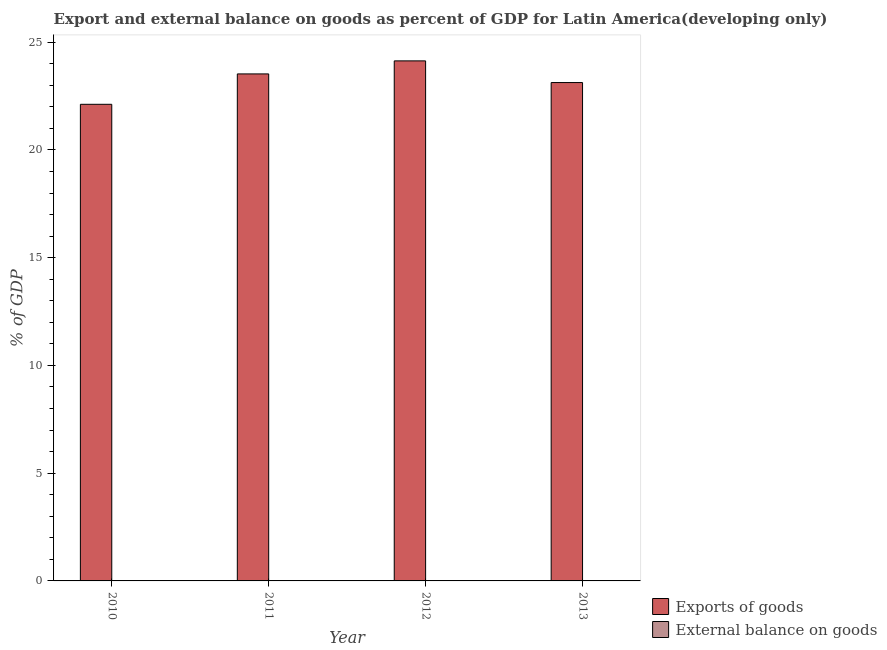How many bars are there on the 4th tick from the left?
Provide a short and direct response. 1. How many bars are there on the 4th tick from the right?
Your response must be concise. 1. What is the external balance on goods as percentage of gdp in 2010?
Offer a terse response. 0. Across all years, what is the maximum export of goods as percentage of gdp?
Keep it short and to the point. 24.13. Across all years, what is the minimum export of goods as percentage of gdp?
Offer a very short reply. 22.12. What is the total export of goods as percentage of gdp in the graph?
Offer a very short reply. 92.9. What is the difference between the export of goods as percentage of gdp in 2010 and that in 2012?
Your answer should be very brief. -2.02. What is the difference between the external balance on goods as percentage of gdp in 2013 and the export of goods as percentage of gdp in 2011?
Provide a short and direct response. 0. In how many years, is the export of goods as percentage of gdp greater than 24 %?
Offer a terse response. 1. What is the ratio of the export of goods as percentage of gdp in 2011 to that in 2012?
Make the answer very short. 0.97. Is the difference between the export of goods as percentage of gdp in 2012 and 2013 greater than the difference between the external balance on goods as percentage of gdp in 2012 and 2013?
Offer a terse response. No. What is the difference between the highest and the second highest export of goods as percentage of gdp?
Keep it short and to the point. 0.61. What is the difference between the highest and the lowest export of goods as percentage of gdp?
Offer a terse response. 2.02. In how many years, is the external balance on goods as percentage of gdp greater than the average external balance on goods as percentage of gdp taken over all years?
Your answer should be very brief. 0. How many bars are there?
Your answer should be very brief. 4. Are all the bars in the graph horizontal?
Keep it short and to the point. No. How many years are there in the graph?
Make the answer very short. 4. What is the difference between two consecutive major ticks on the Y-axis?
Provide a short and direct response. 5. Where does the legend appear in the graph?
Offer a terse response. Bottom right. How many legend labels are there?
Your answer should be compact. 2. What is the title of the graph?
Provide a short and direct response. Export and external balance on goods as percent of GDP for Latin America(developing only). What is the label or title of the X-axis?
Your answer should be compact. Year. What is the label or title of the Y-axis?
Your response must be concise. % of GDP. What is the % of GDP of Exports of goods in 2010?
Provide a succinct answer. 22.12. What is the % of GDP of Exports of goods in 2011?
Your response must be concise. 23.53. What is the % of GDP of Exports of goods in 2012?
Your answer should be very brief. 24.13. What is the % of GDP of External balance on goods in 2012?
Offer a very short reply. 0. What is the % of GDP of Exports of goods in 2013?
Ensure brevity in your answer.  23.13. What is the % of GDP in External balance on goods in 2013?
Offer a terse response. 0. Across all years, what is the maximum % of GDP of Exports of goods?
Offer a terse response. 24.13. Across all years, what is the minimum % of GDP of Exports of goods?
Provide a succinct answer. 22.12. What is the total % of GDP in Exports of goods in the graph?
Your answer should be very brief. 92.9. What is the difference between the % of GDP in Exports of goods in 2010 and that in 2011?
Offer a very short reply. -1.41. What is the difference between the % of GDP in Exports of goods in 2010 and that in 2012?
Keep it short and to the point. -2.02. What is the difference between the % of GDP in Exports of goods in 2010 and that in 2013?
Your response must be concise. -1.01. What is the difference between the % of GDP of Exports of goods in 2011 and that in 2012?
Make the answer very short. -0.61. What is the difference between the % of GDP of Exports of goods in 2011 and that in 2013?
Your answer should be compact. 0.4. What is the average % of GDP in Exports of goods per year?
Provide a short and direct response. 23.23. What is the ratio of the % of GDP of Exports of goods in 2010 to that in 2011?
Ensure brevity in your answer.  0.94. What is the ratio of the % of GDP of Exports of goods in 2010 to that in 2012?
Keep it short and to the point. 0.92. What is the ratio of the % of GDP of Exports of goods in 2010 to that in 2013?
Keep it short and to the point. 0.96. What is the ratio of the % of GDP in Exports of goods in 2011 to that in 2012?
Ensure brevity in your answer.  0.97. What is the ratio of the % of GDP in Exports of goods in 2011 to that in 2013?
Your answer should be compact. 1.02. What is the ratio of the % of GDP in Exports of goods in 2012 to that in 2013?
Offer a terse response. 1.04. What is the difference between the highest and the second highest % of GDP in Exports of goods?
Ensure brevity in your answer.  0.61. What is the difference between the highest and the lowest % of GDP of Exports of goods?
Your response must be concise. 2.02. 